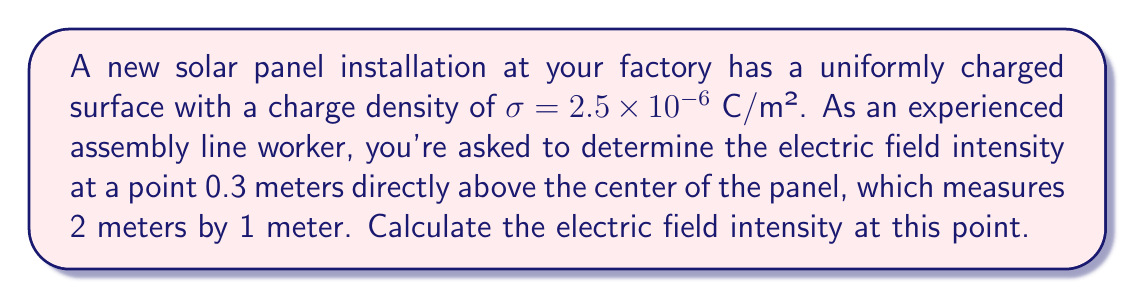Provide a solution to this math problem. To solve this problem, we'll use the principle of superposition and integrate over the charged surface. The steps are as follows:

1) For an infinite charged plane, the electric field is given by:
   $$E = \frac{\sigma}{2\epsilon_0}$$
   where $\sigma$ is the surface charge density and $\epsilon_0$ is the permittivity of free space.

2) However, our solar panel is finite. We can use the formula for the electric field above the center of a finite rectangular sheet:
   $$E = \frac{\sigma}{4\pi\epsilon_0}\left[\frac{xy}{\sqrt{x^2+y^2+z^2}}\left(\frac{1}{x^2+z^2}+\frac{1}{y^2+z^2}\right)\right]$$
   where $x$ and $y$ are half the length and width of the rectangle, and $z$ is the distance above the center.

3) Given:
   - $\sigma = 2.5 \times 10^{-6}$ C/m²
   - $x = 1$ m (half of 2 m)
   - $y = 0.5$ m (half of 1 m)
   - $z = 0.3$ m

4) $\epsilon_0 = 8.854 \times 10^{-12}$ F/m

5) Substituting these values:
   $$E = \frac{2.5 \times 10^{-6}}{4\pi(8.854 \times 10^{-12})}\left[\frac{1 \times 0.5}{\sqrt{1^2+0.5^2+0.3^2}}\left(\frac{1}{1^2+0.3^2}+\frac{1}{0.5^2+0.3^2}\right)\right]$$

6) Simplifying:
   $$E = 70,583 \times \left[\frac{0.5}{1.15}\left(\frac{1}{1.09}+\frac{1}{0.34}\right)\right]$$

7) Calculating:
   $$E = 70,583 \times 0.435 \times 3.85 = 118,146 \text{ V/m}$$

8) Rounding to three significant figures:
   $$E \approx 118,000 \text{ V/m}$$
Answer: $118,000 \text{ V/m}$ 